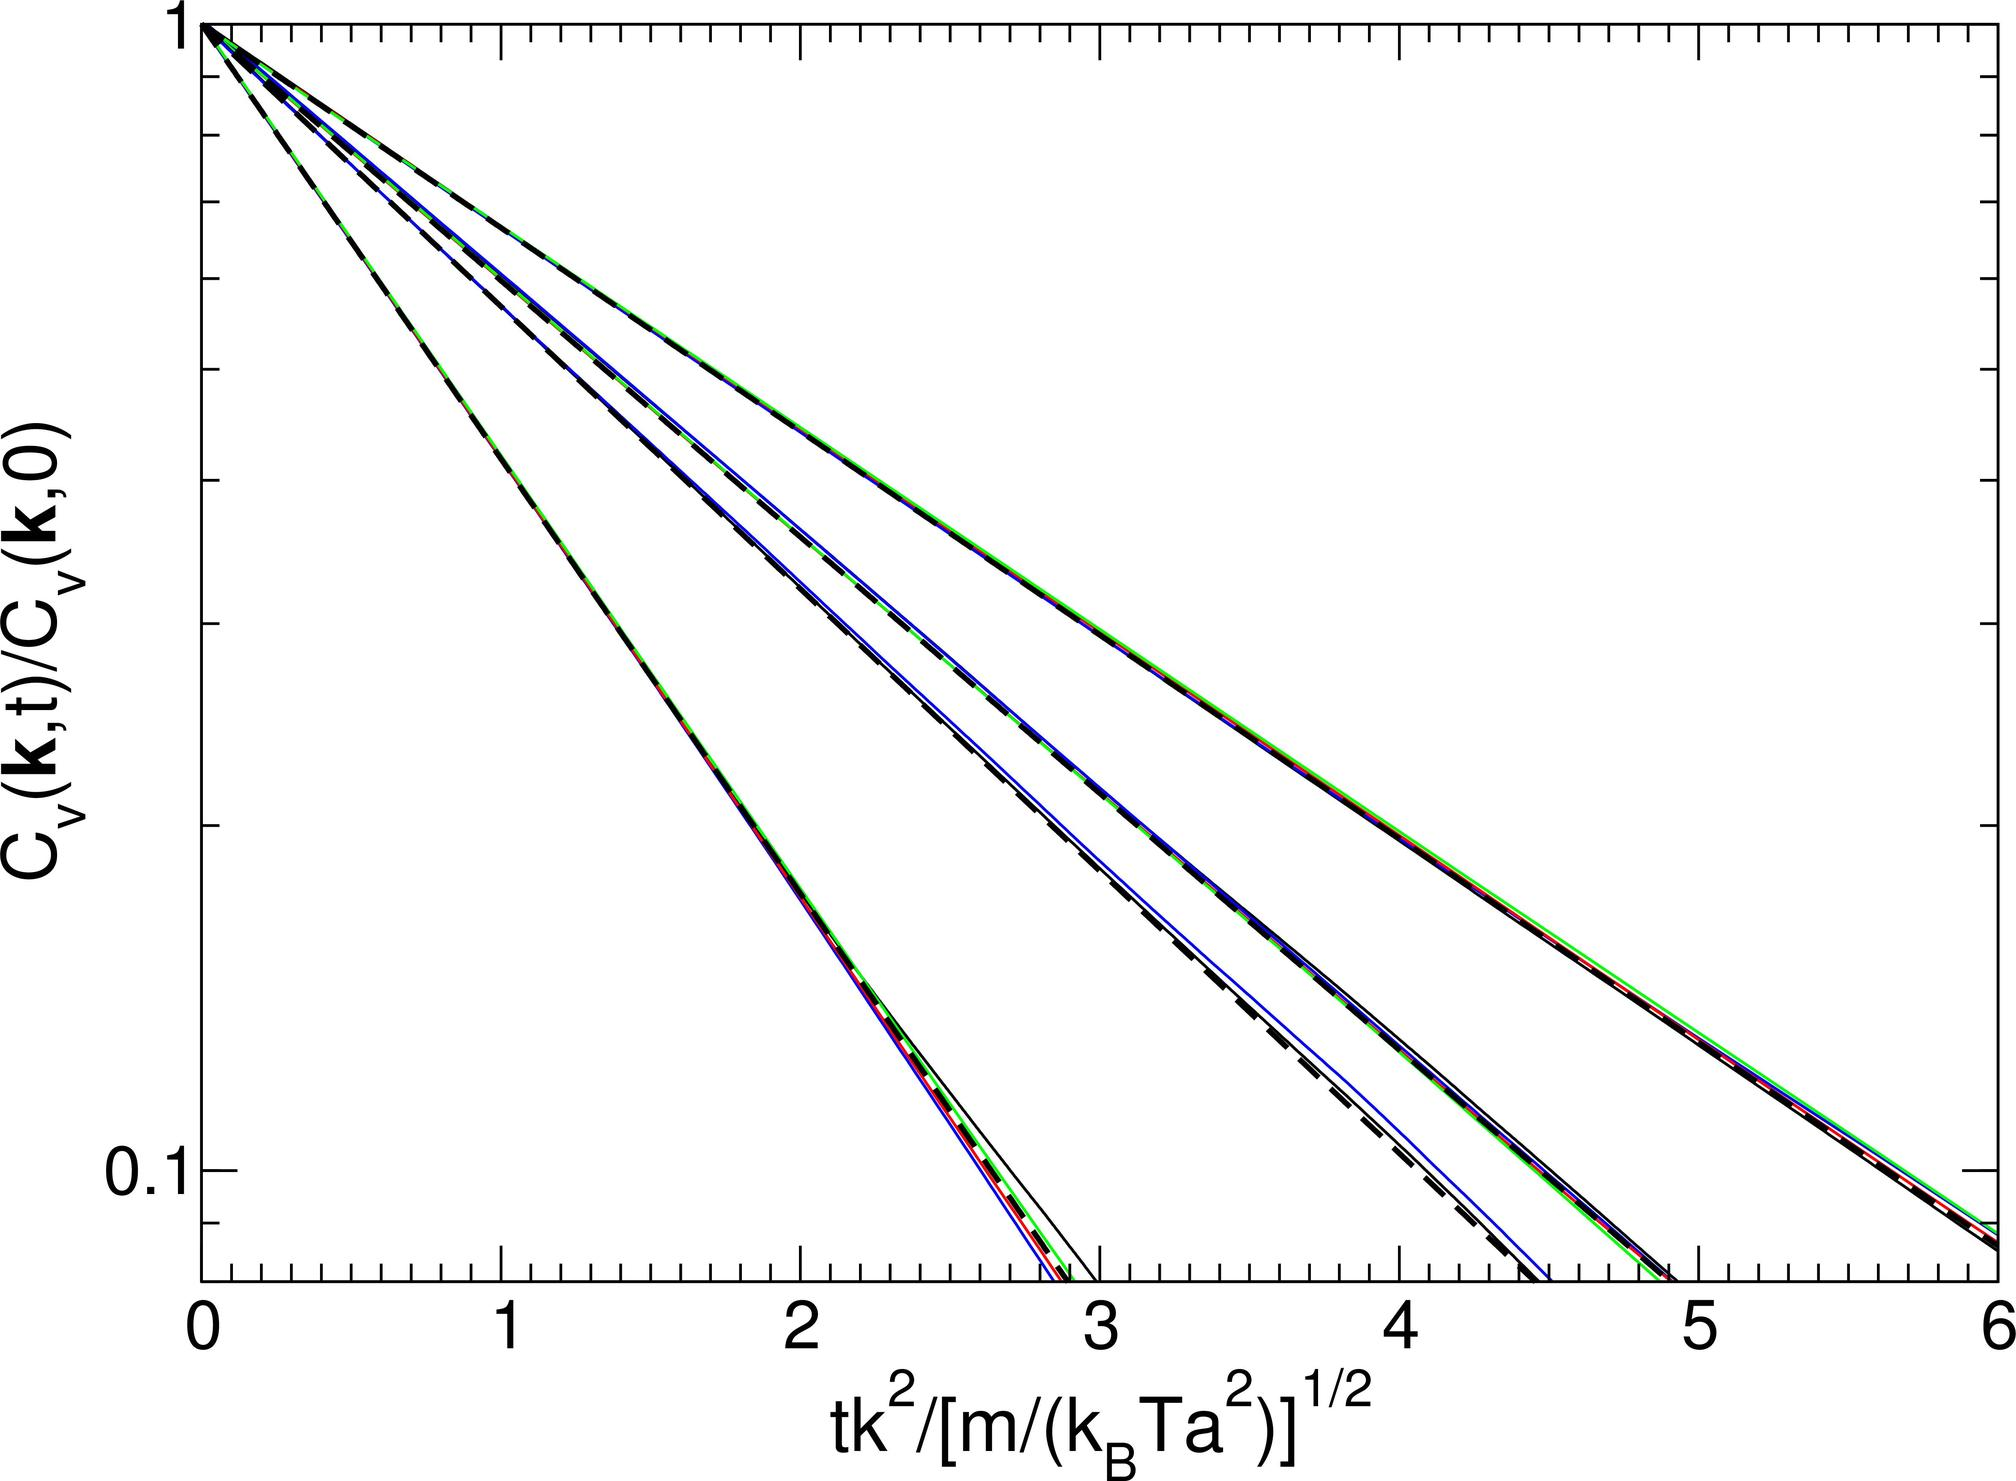What could be the potential impact of varying the parameter \( m \) while keeping \( t \), \( K \), \( k_B \), and \( T_a \) constant based on the graph? Varying the parameter \( m \), with the other parameters \( t \), \( K \), \( k_B \), and \( T_a \) held constant, impacts the graph by shifting the position of the curves along the x-axis. Specifically, since \( m \) is found in the denominator within the square root that defines the x-axis scale, increasing \( m \) leads to a larger denominator, thus requiring a proportionally larger value of \( tK^2 \) to maintain a given x-axis value. This results in the physical shifting of the curve to the right, corresponding to higher x-axis values. Conversely, decreasing \( m \) reduces the value in the denominator, causing the curve to shift left towards lower x-axis values. Hence, the most correct answer among the provided options is A, indicating a shift towards higher values on the x-axis. 